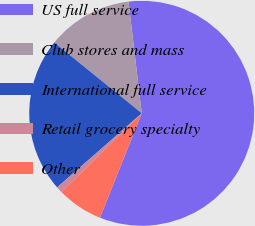Convert chart. <chart><loc_0><loc_0><loc_500><loc_500><pie_chart><fcel>US full service<fcel>Club stores and mass<fcel>International full service<fcel>Retail grocery specialty<fcel>Other<nl><fcel>57.93%<fcel>12.3%<fcel>22.28%<fcel>0.89%<fcel>6.6%<nl></chart> 